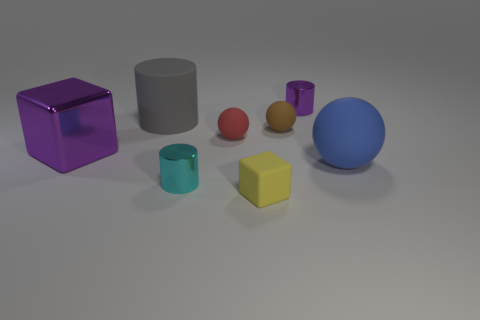Subtract all red balls. How many balls are left? 2 Add 1 blocks. How many objects exist? 9 Subtract all yellow blocks. How many blocks are left? 1 Subtract all cylinders. How many objects are left? 5 Subtract all red blocks. How many gray cylinders are left? 1 Subtract all tiny red matte objects. Subtract all red things. How many objects are left? 6 Add 7 large cylinders. How many large cylinders are left? 8 Add 5 large gray metal objects. How many large gray metal objects exist? 5 Subtract 1 gray cylinders. How many objects are left? 7 Subtract 1 blocks. How many blocks are left? 1 